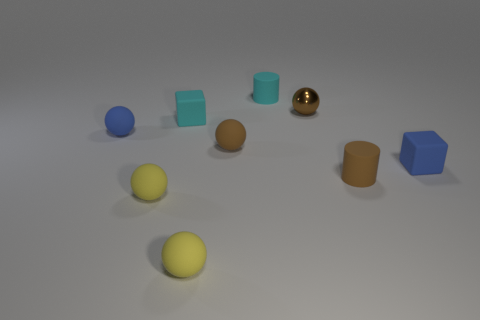Is there a tiny ball that has the same color as the tiny metal thing?
Make the answer very short. Yes. What number of things are objects that are in front of the blue sphere or rubber blocks?
Provide a succinct answer. 6. How many other objects are the same size as the brown metallic sphere?
Your answer should be compact. 8. There is a brown ball that is behind the blue matte object on the left side of the small block in front of the blue rubber ball; what is it made of?
Offer a terse response. Metal. What number of balls are small matte objects or small cyan objects?
Provide a short and direct response. 4. Is the number of things that are in front of the cyan cube greater than the number of blue matte spheres right of the metallic sphere?
Your response must be concise. Yes. There is a tiny blue rubber object on the right side of the tiny cyan cylinder; how many tiny cyan cylinders are right of it?
Make the answer very short. 0. What number of objects are tiny balls or cubes?
Make the answer very short. 7. What is the material of the cyan cube?
Make the answer very short. Rubber. What number of balls are both in front of the small shiny ball and behind the brown rubber sphere?
Ensure brevity in your answer.  1. 